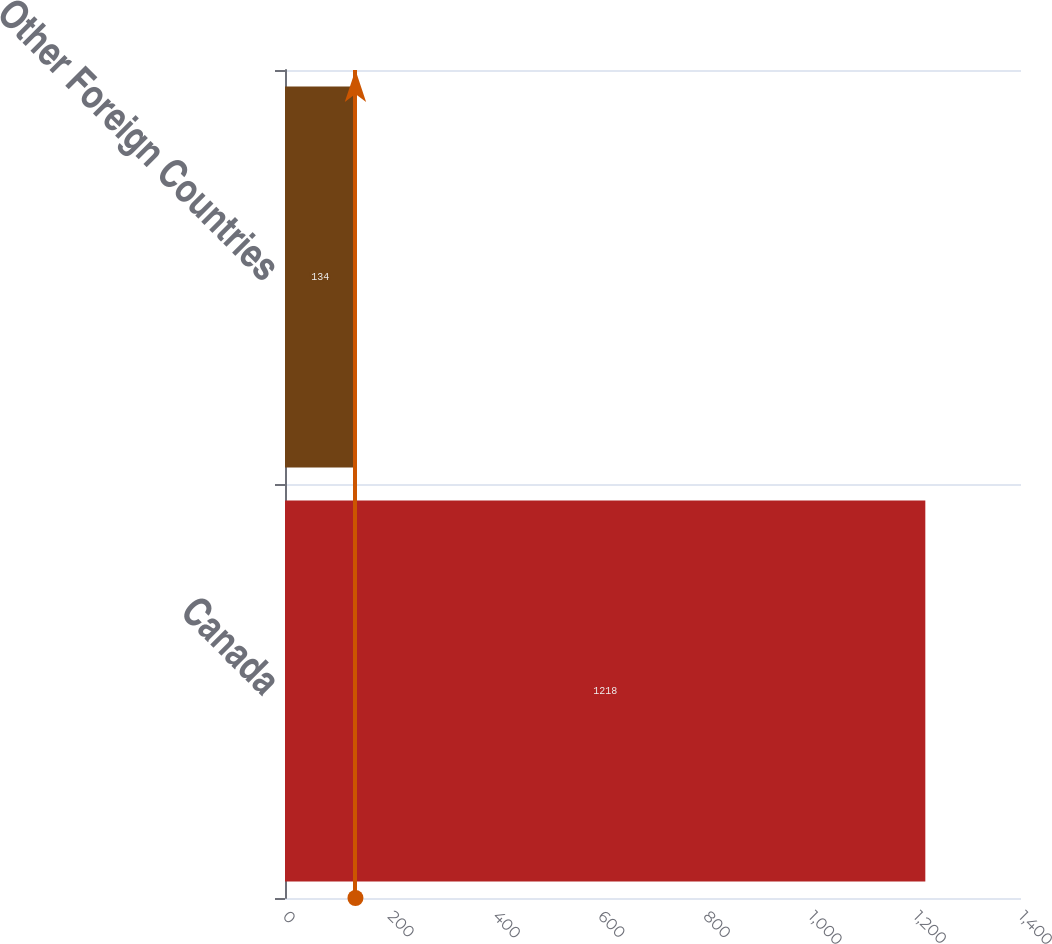<chart> <loc_0><loc_0><loc_500><loc_500><bar_chart><fcel>Canada<fcel>Other Foreign Countries<nl><fcel>1218<fcel>134<nl></chart> 